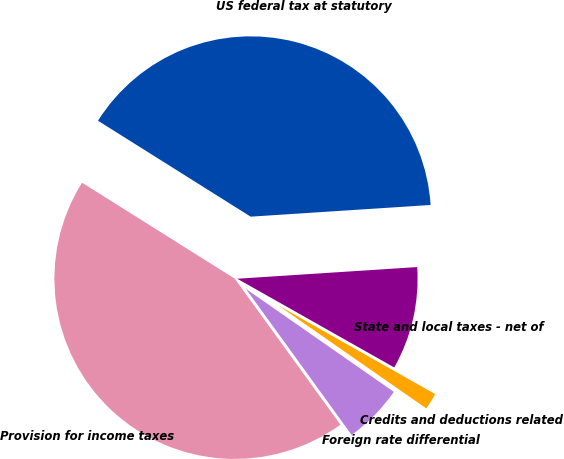Convert chart. <chart><loc_0><loc_0><loc_500><loc_500><pie_chart><fcel>US federal tax at statutory<fcel>State and local taxes - net of<fcel>Credits and deductions related<fcel>Foreign rate differential<fcel>Provision for income taxes<nl><fcel>40.04%<fcel>9.22%<fcel>1.49%<fcel>5.35%<fcel>43.9%<nl></chart> 